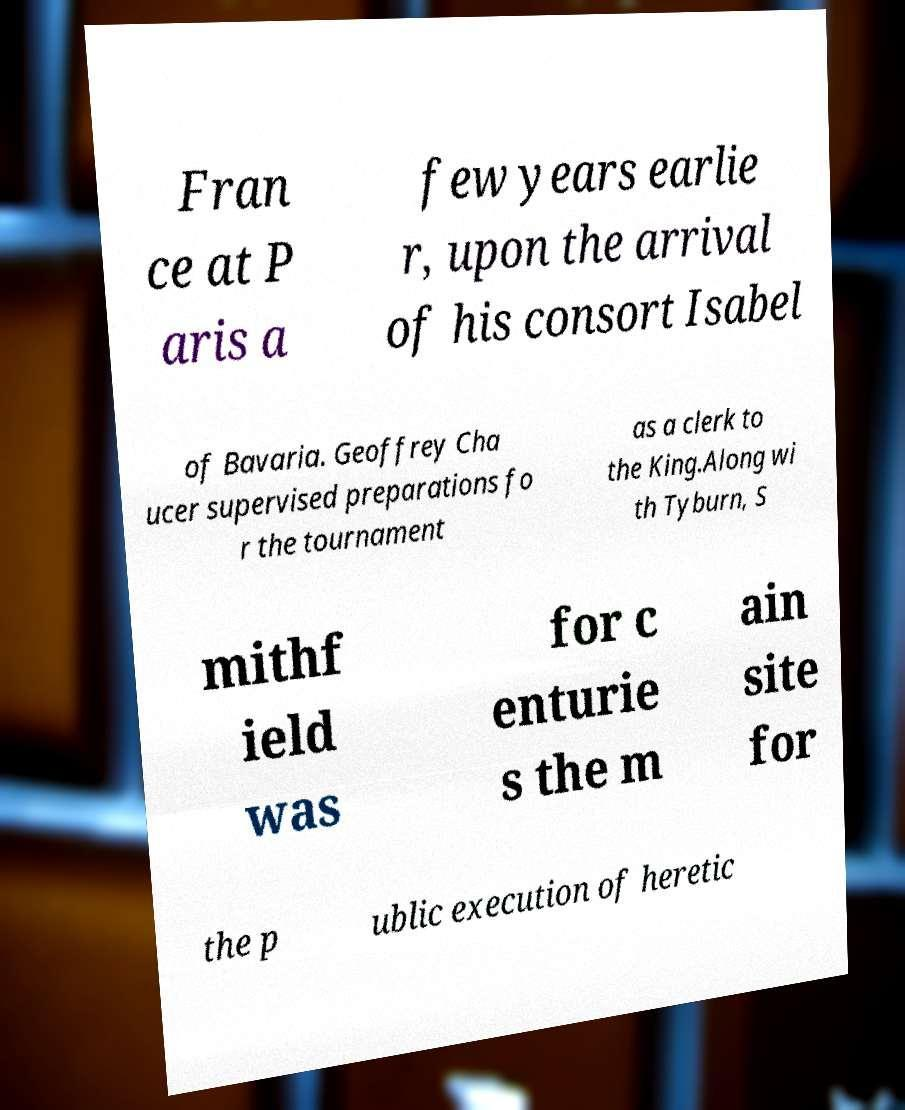Can you accurately transcribe the text from the provided image for me? Fran ce at P aris a few years earlie r, upon the arrival of his consort Isabel of Bavaria. Geoffrey Cha ucer supervised preparations fo r the tournament as a clerk to the King.Along wi th Tyburn, S mithf ield was for c enturie s the m ain site for the p ublic execution of heretic 